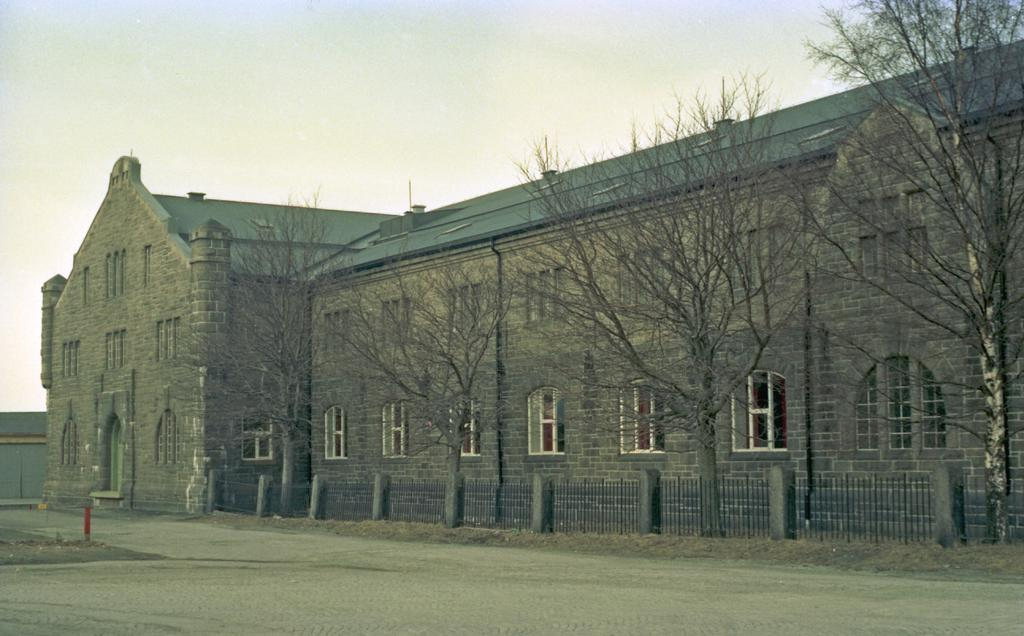What type of building is in the image? There is a bungalow in the image. What are some features of the bungalow? The bungalow has walls and windows. What other structures can be seen in the image? There are pillars, grills, and a pole in the image. What natural elements are present in the image? There are trees and the sky is visible in the background of the image. What is the landscape like in the image? There is a road at the bottom of the image. Where is the mitten located in the image? There is no mitten present in the image. What type of waste is being disposed of in the image? There is no waste disposal visible in the image. 